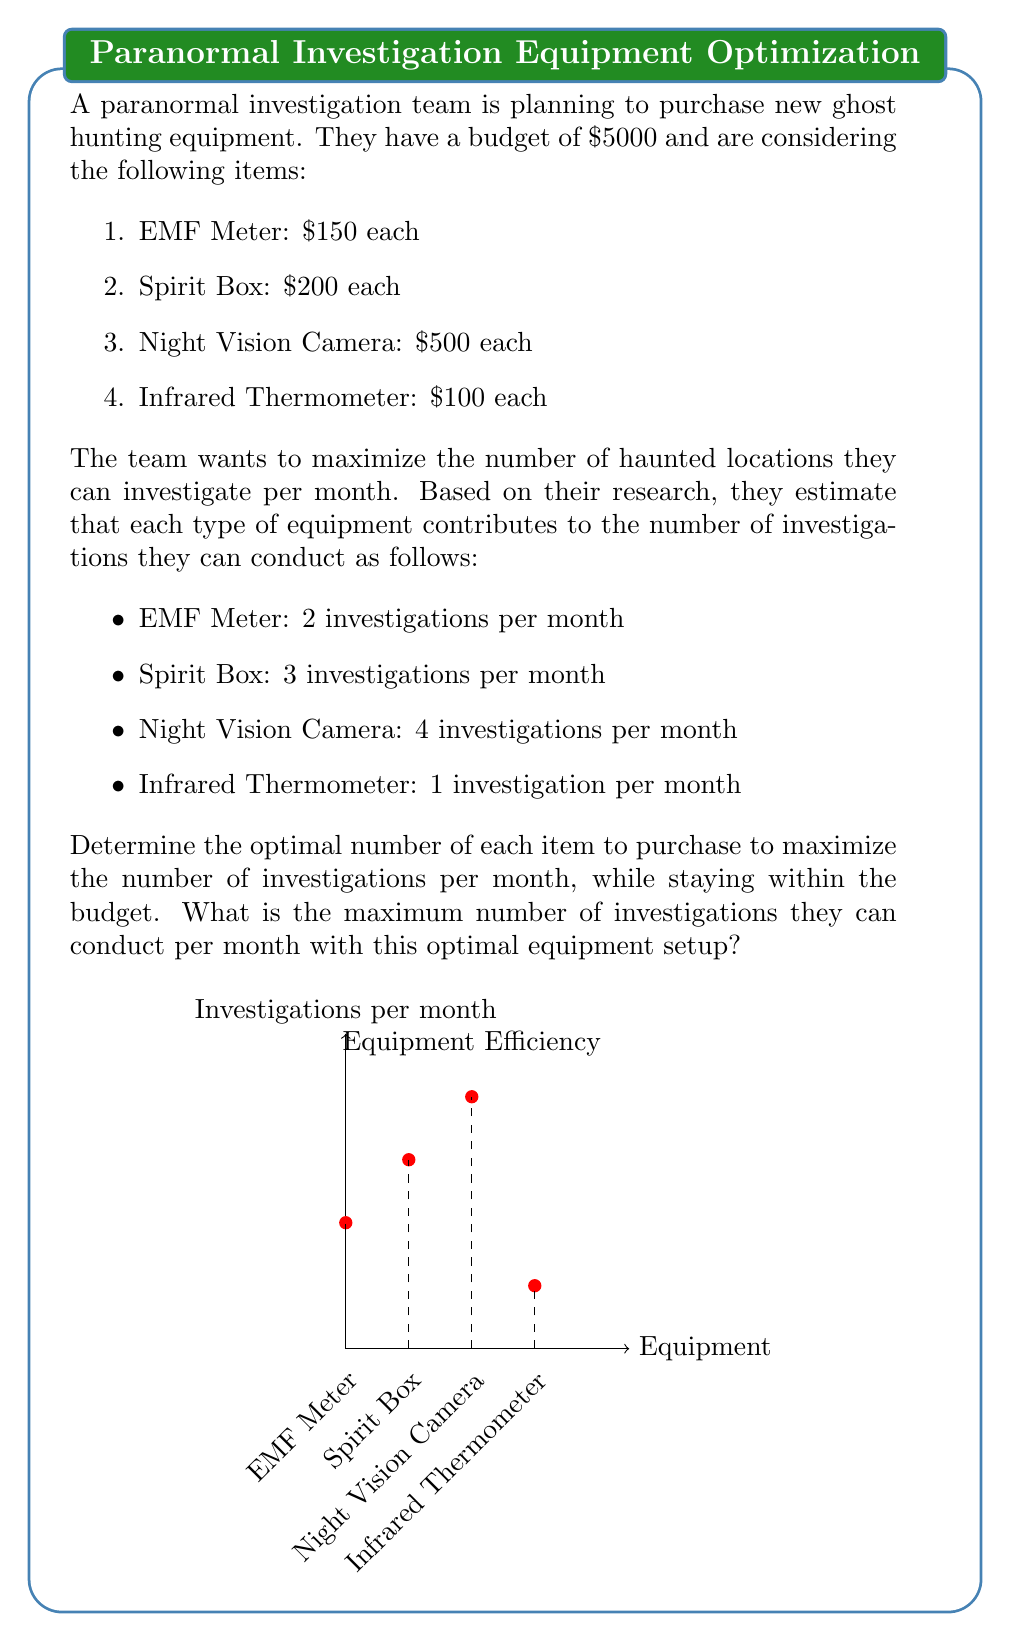Show me your answer to this math problem. To solve this problem, we'll use the simplex method for linear programming. Let's define our variables:

$x_1$ = number of EMF Meters
$x_2$ = number of Spirit Boxes
$x_3$ = number of Night Vision Cameras
$x_4$ = number of Infrared Thermometers

Our objective function is to maximize the number of investigations per month:

$$\text{Maximize } Z = 2x_1 + 3x_2 + 4x_3 + x_4$$

Subject to the budget constraint:

$$150x_1 + 200x_2 + 500x_3 + 100x_4 \leq 5000$$

And non-negativity constraints:

$$x_1, x_2, x_3, x_4 \geq 0$$

We can solve this using the simplex method, but for simplicity, let's use a more intuitive approach:

1. The Night Vision Camera gives the most investigations per dollar spent:
   $4 / 500 = 0.008$ investigations per dollar

2. We should buy as many Night Vision Cameras as possible:
   $5000 / 500 = 10$ cameras

3. This leaves us with $5000 - (10 * 500) = 0$ budget

4. The optimal solution is to buy 10 Night Vision Cameras and no other equipment.

5. The maximum number of investigations per month is:
   $10 * 4 = 40$ investigations
Answer: 40 investigations per month 